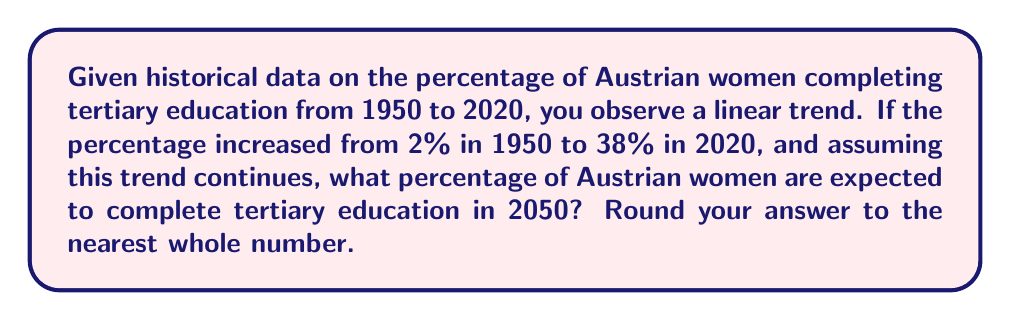Show me your answer to this math problem. To solve this problem, we'll use linear regression and time series analysis:

1. Identify the time period:
   Start year: 1950
   End year: 2020
   Total years: 2020 - 1950 = 70 years

2. Calculate the rate of change:
   Change in percentage: 38% - 2% = 36%
   Rate of change per year: $\frac{36\%}{70 \text{ years}} = 0.5143\%$ per year

3. Set up the linear equation:
   Let $y$ be the percentage and $x$ be the number of years since 1950.
   $y = mx + b$, where $m$ is the slope (rate of change) and $b$ is the y-intercept (initial value)
   $y = 0.5143x + 2$

4. Calculate the prediction for 2050:
   Years since 1950: 2050 - 1950 = 100
   $y = 0.5143 \cdot 100 + 2 = 51.43 + 2 = 53.43\%$

5. Round to the nearest whole number:
   53.43% rounds to 53%
Answer: 53% 